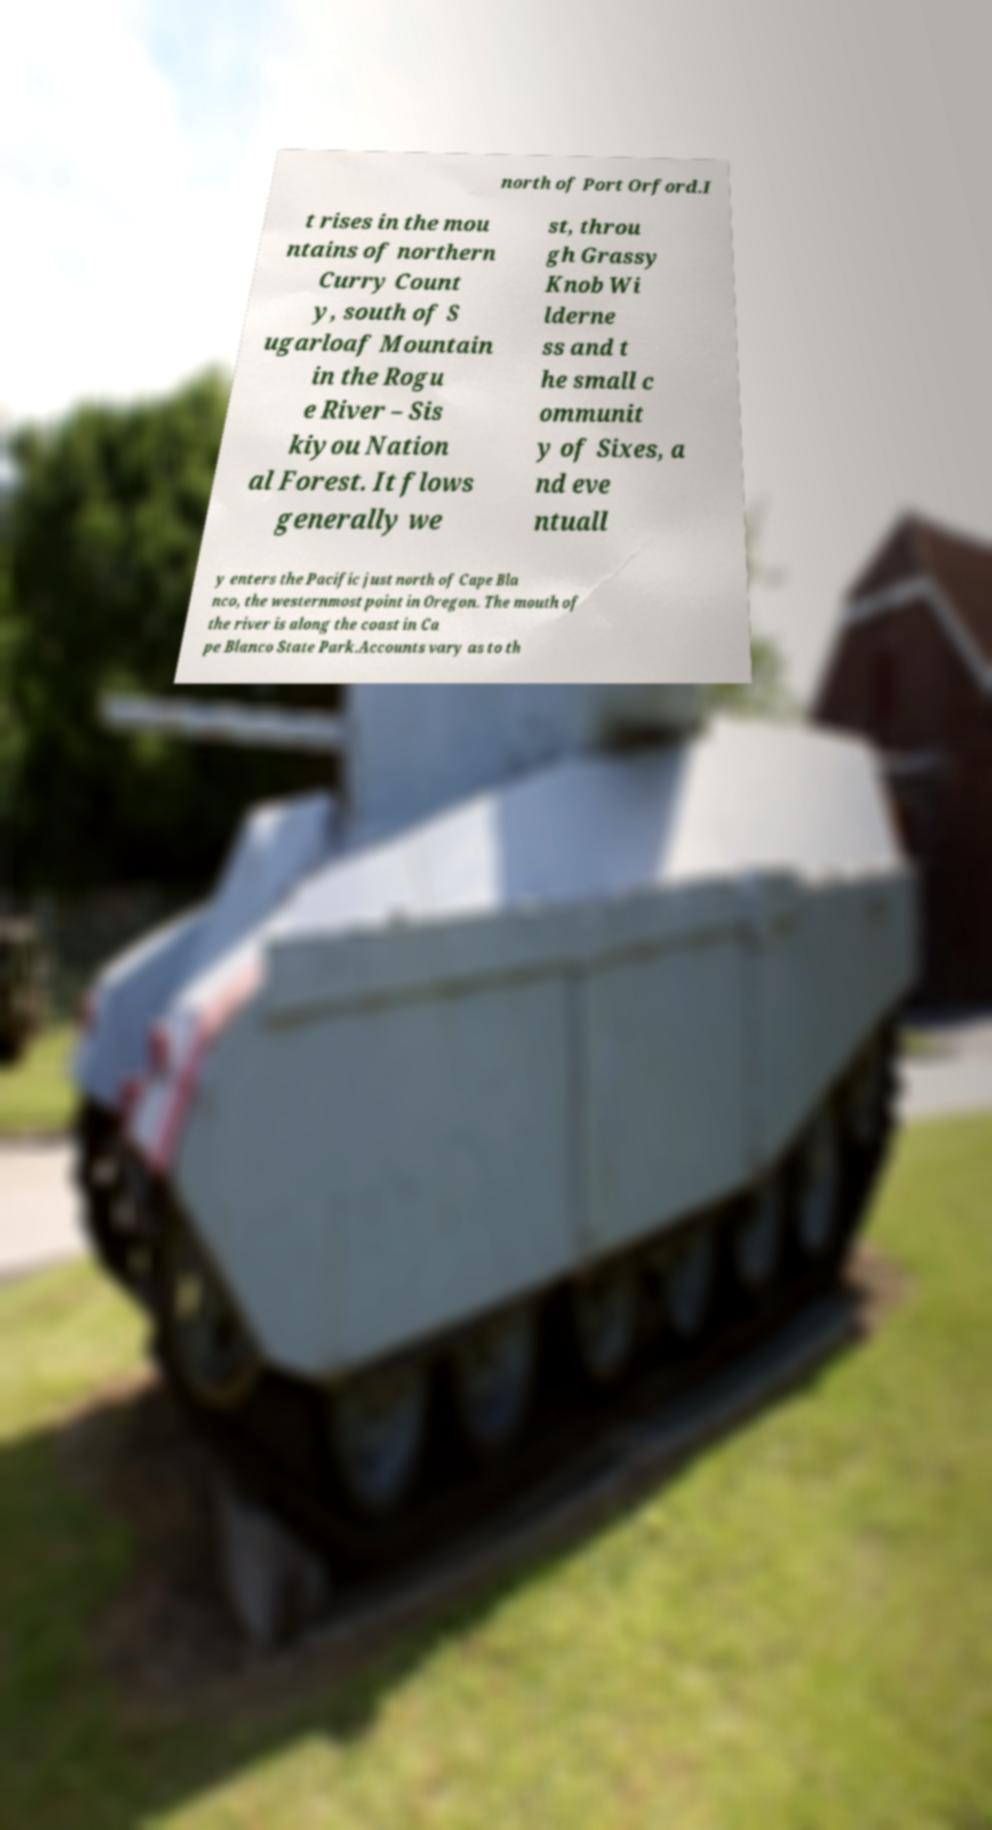There's text embedded in this image that I need extracted. Can you transcribe it verbatim? north of Port Orford.I t rises in the mou ntains of northern Curry Count y, south of S ugarloaf Mountain in the Rogu e River – Sis kiyou Nation al Forest. It flows generally we st, throu gh Grassy Knob Wi lderne ss and t he small c ommunit y of Sixes, a nd eve ntuall y enters the Pacific just north of Cape Bla nco, the westernmost point in Oregon. The mouth of the river is along the coast in Ca pe Blanco State Park.Accounts vary as to th 